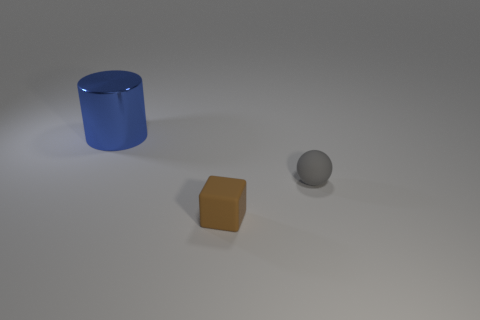Is there any other thing that is the same material as the big cylinder?
Make the answer very short. No. Are there any other things that have the same size as the blue object?
Ensure brevity in your answer.  No. There is a object behind the tiny object on the right side of the brown object; what shape is it?
Offer a terse response. Cylinder. Is the big object the same shape as the small gray thing?
Ensure brevity in your answer.  No. Is the color of the large metal cylinder the same as the small rubber sphere?
Offer a terse response. No. There is a tiny rubber object in front of the tiny thing behind the rubber block; what number of matte things are to the right of it?
Ensure brevity in your answer.  1. What shape is the tiny object that is the same material as the small brown cube?
Keep it short and to the point. Sphere. There is a sphere behind the tiny matte object left of the small thing on the right side of the rubber cube; what is it made of?
Your answer should be compact. Rubber. What number of things are brown things that are in front of the gray sphere or small brown cubes?
Make the answer very short. 1. How many other things are the same shape as the metallic object?
Ensure brevity in your answer.  0. 